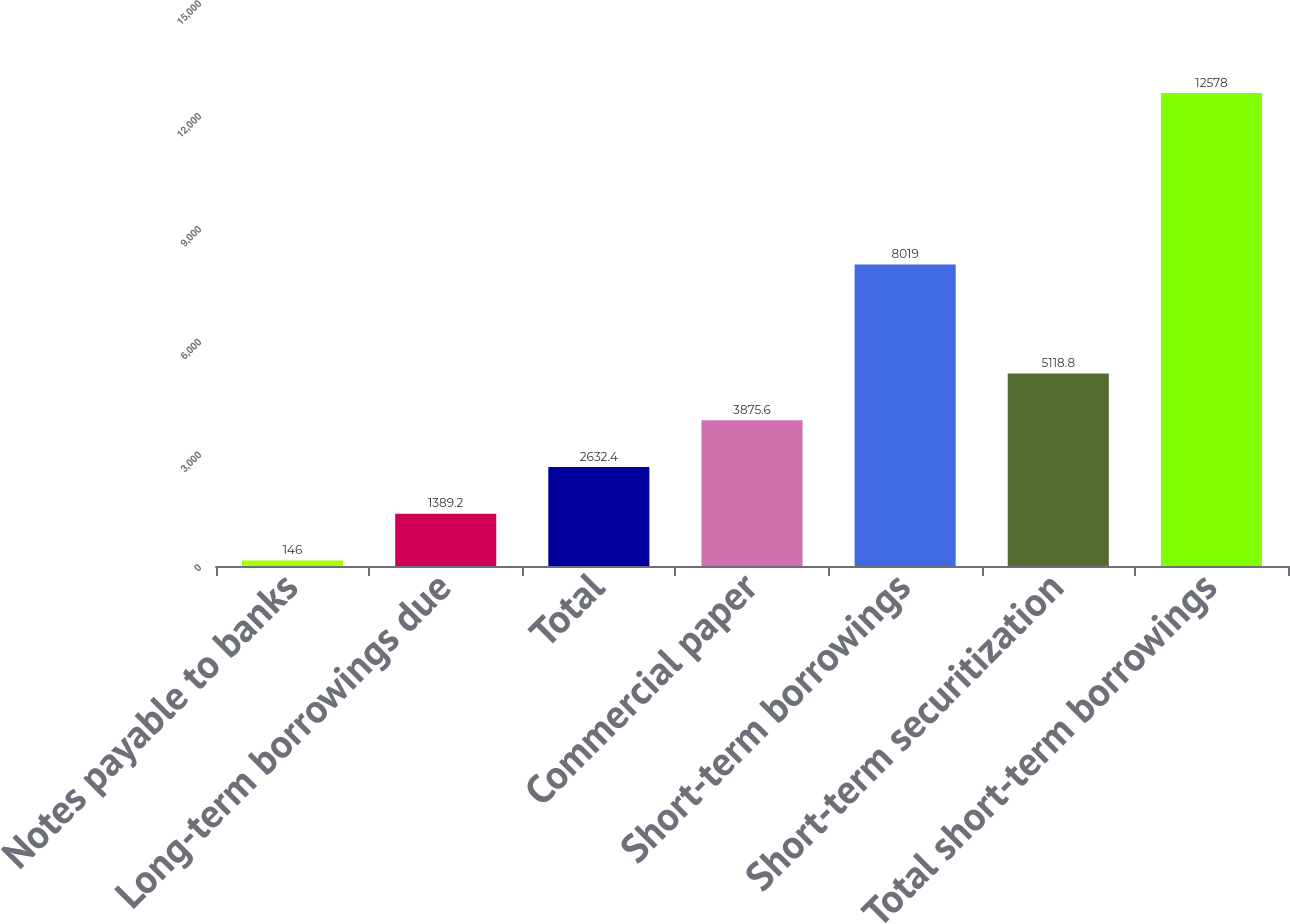Convert chart to OTSL. <chart><loc_0><loc_0><loc_500><loc_500><bar_chart><fcel>Notes payable to banks<fcel>Long-term borrowings due<fcel>Total<fcel>Commercial paper<fcel>Short-term borrowings<fcel>Short-term securitization<fcel>Total short-term borrowings<nl><fcel>146<fcel>1389.2<fcel>2632.4<fcel>3875.6<fcel>8019<fcel>5118.8<fcel>12578<nl></chart> 